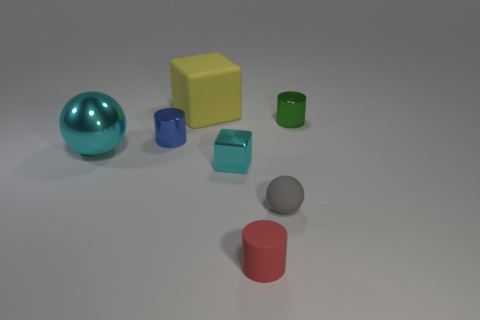Subtract all shiny cylinders. How many cylinders are left? 1 Add 2 large cyan shiny blocks. How many objects exist? 9 Subtract 1 cylinders. How many cylinders are left? 2 Subtract all balls. How many objects are left? 5 Subtract all gray cylinders. Subtract all blue spheres. How many cylinders are left? 3 Add 5 large cylinders. How many large cylinders exist? 5 Subtract 0 purple blocks. How many objects are left? 7 Subtract all small red metallic cylinders. Subtract all gray matte balls. How many objects are left? 6 Add 6 tiny red cylinders. How many tiny red cylinders are left? 7 